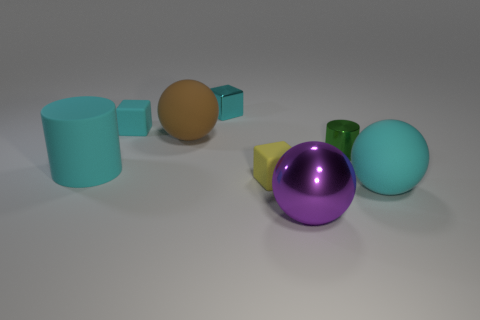There is a big purple thing that is the same shape as the big brown thing; what is it made of?
Give a very brief answer. Metal. Does the ball right of the tiny green metallic object have the same material as the cyan cylinder?
Your answer should be compact. Yes. Is the number of small objects right of the tiny yellow rubber thing greater than the number of cyan things that are in front of the large brown thing?
Keep it short and to the point. No. What is the size of the cyan matte cylinder?
Offer a terse response. Large. What is the shape of the large brown object that is made of the same material as the tiny yellow thing?
Keep it short and to the point. Sphere. Do the tiny metallic object in front of the big brown thing and the large brown object have the same shape?
Offer a terse response. No. What number of objects are either tiny cubes or small green shiny cylinders?
Your response must be concise. 4. The cyan thing that is to the right of the big brown matte sphere and left of the tiny yellow rubber object is made of what material?
Make the answer very short. Metal. Is the size of the cyan cylinder the same as the yellow thing?
Make the answer very short. No. How big is the purple metal ball that is to the right of the small cube that is behind the small cyan matte object?
Your answer should be compact. Large. 